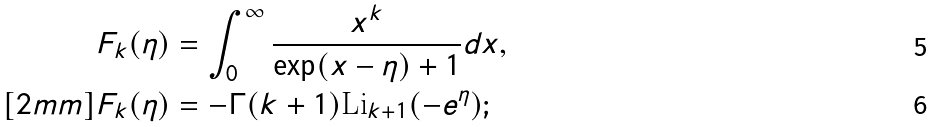<formula> <loc_0><loc_0><loc_500><loc_500>F _ { k } ( \eta ) & = \int _ { 0 } ^ { \infty } \frac { x ^ { k } } { \exp ( x - \eta ) + 1 } d x , \\ [ 2 m m ] F _ { k } ( \eta ) & = - \Gamma ( k + 1 ) \text {Li} _ { k + 1 } ( - e ^ { \eta } ) ;</formula> 